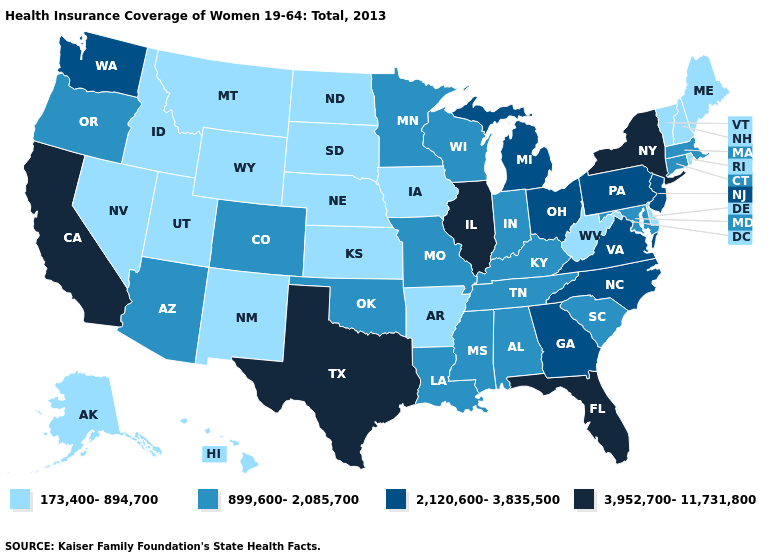Name the states that have a value in the range 3,952,700-11,731,800?
Quick response, please. California, Florida, Illinois, New York, Texas. Among the states that border Colorado , which have the highest value?
Be succinct. Arizona, Oklahoma. Does Wisconsin have a higher value than Michigan?
Short answer required. No. Which states have the lowest value in the Northeast?
Be succinct. Maine, New Hampshire, Rhode Island, Vermont. What is the value of Kansas?
Give a very brief answer. 173,400-894,700. Does Maine have the same value as Oregon?
Keep it brief. No. Does Rhode Island have a lower value than Delaware?
Be succinct. No. What is the lowest value in the USA?
Concise answer only. 173,400-894,700. Name the states that have a value in the range 2,120,600-3,835,500?
Be succinct. Georgia, Michigan, New Jersey, North Carolina, Ohio, Pennsylvania, Virginia, Washington. What is the value of Vermont?
Write a very short answer. 173,400-894,700. What is the highest value in states that border North Dakota?
Give a very brief answer. 899,600-2,085,700. Name the states that have a value in the range 2,120,600-3,835,500?
Concise answer only. Georgia, Michigan, New Jersey, North Carolina, Ohio, Pennsylvania, Virginia, Washington. What is the highest value in the USA?
Concise answer only. 3,952,700-11,731,800. Which states have the lowest value in the MidWest?
Answer briefly. Iowa, Kansas, Nebraska, North Dakota, South Dakota. Name the states that have a value in the range 173,400-894,700?
Answer briefly. Alaska, Arkansas, Delaware, Hawaii, Idaho, Iowa, Kansas, Maine, Montana, Nebraska, Nevada, New Hampshire, New Mexico, North Dakota, Rhode Island, South Dakota, Utah, Vermont, West Virginia, Wyoming. 